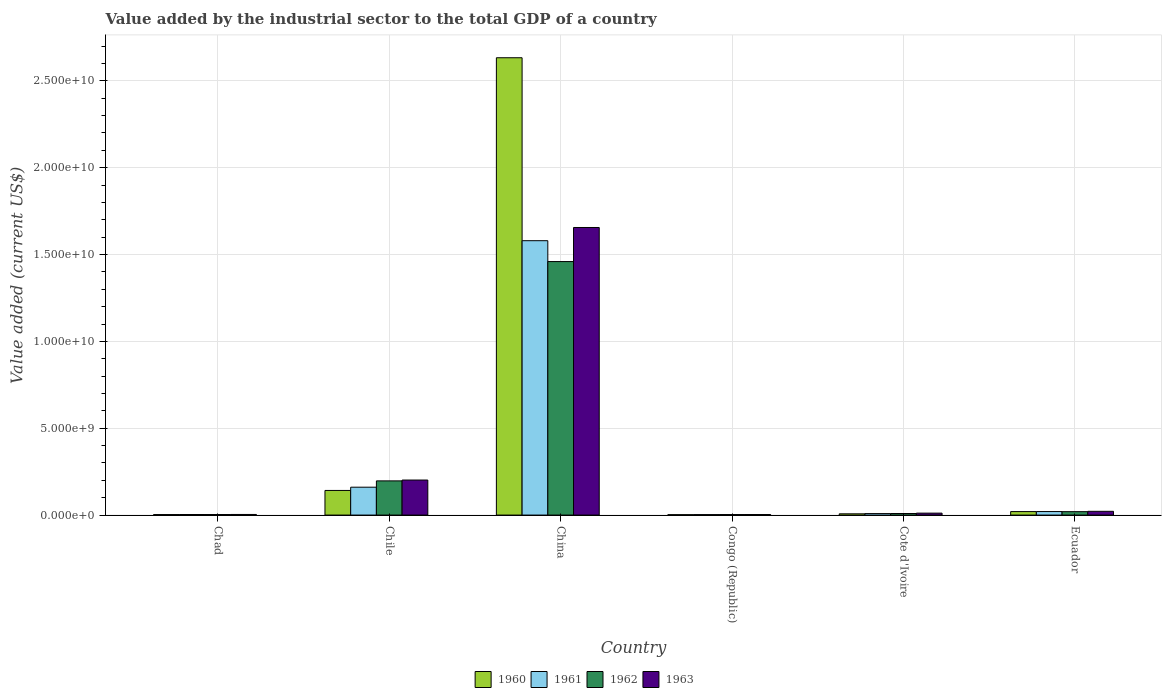How many different coloured bars are there?
Keep it short and to the point. 4. How many groups of bars are there?
Give a very brief answer. 6. How many bars are there on the 5th tick from the left?
Ensure brevity in your answer.  4. How many bars are there on the 5th tick from the right?
Provide a succinct answer. 4. What is the label of the 5th group of bars from the left?
Provide a succinct answer. Cote d'Ivoire. In how many cases, is the number of bars for a given country not equal to the number of legend labels?
Offer a very short reply. 0. What is the value added by the industrial sector to the total GDP in 1961 in China?
Your answer should be very brief. 1.58e+1. Across all countries, what is the maximum value added by the industrial sector to the total GDP in 1962?
Provide a succinct answer. 1.46e+1. Across all countries, what is the minimum value added by the industrial sector to the total GDP in 1963?
Offer a terse response. 3.06e+07. In which country was the value added by the industrial sector to the total GDP in 1960 minimum?
Offer a terse response. Congo (Republic). What is the total value added by the industrial sector to the total GDP in 1962 in the graph?
Give a very brief answer. 1.69e+1. What is the difference between the value added by the industrial sector to the total GDP in 1963 in Chile and that in Cote d'Ivoire?
Ensure brevity in your answer.  1.91e+09. What is the difference between the value added by the industrial sector to the total GDP in 1961 in Congo (Republic) and the value added by the industrial sector to the total GDP in 1960 in Cote d'Ivoire?
Offer a terse response. -4.44e+07. What is the average value added by the industrial sector to the total GDP in 1961 per country?
Keep it short and to the point. 2.96e+09. What is the difference between the value added by the industrial sector to the total GDP of/in 1963 and value added by the industrial sector to the total GDP of/in 1962 in Congo (Republic)?
Provide a short and direct response. 8.16e+05. In how many countries, is the value added by the industrial sector to the total GDP in 1961 greater than 21000000000 US$?
Give a very brief answer. 0. What is the ratio of the value added by the industrial sector to the total GDP in 1962 in Chad to that in Congo (Republic)?
Provide a short and direct response. 1.07. What is the difference between the highest and the second highest value added by the industrial sector to the total GDP in 1963?
Your response must be concise. 1.63e+1. What is the difference between the highest and the lowest value added by the industrial sector to the total GDP in 1961?
Provide a short and direct response. 1.58e+1. In how many countries, is the value added by the industrial sector to the total GDP in 1963 greater than the average value added by the industrial sector to the total GDP in 1963 taken over all countries?
Provide a short and direct response. 1. Is the sum of the value added by the industrial sector to the total GDP in 1960 in Chad and Chile greater than the maximum value added by the industrial sector to the total GDP in 1961 across all countries?
Ensure brevity in your answer.  No. What does the 1st bar from the left in Chile represents?
Your answer should be compact. 1960. How many bars are there?
Your response must be concise. 24. Are all the bars in the graph horizontal?
Your response must be concise. No. What is the difference between two consecutive major ticks on the Y-axis?
Offer a very short reply. 5.00e+09. Are the values on the major ticks of Y-axis written in scientific E-notation?
Keep it short and to the point. Yes. Does the graph contain any zero values?
Your answer should be very brief. No. Does the graph contain grids?
Provide a succinct answer. Yes. Where does the legend appear in the graph?
Your response must be concise. Bottom center. How many legend labels are there?
Offer a very short reply. 4. How are the legend labels stacked?
Your answer should be very brief. Horizontal. What is the title of the graph?
Make the answer very short. Value added by the industrial sector to the total GDP of a country. What is the label or title of the X-axis?
Your answer should be compact. Country. What is the label or title of the Y-axis?
Make the answer very short. Value added (current US$). What is the Value added (current US$) of 1960 in Chad?
Offer a terse response. 2.88e+07. What is the Value added (current US$) in 1961 in Chad?
Your answer should be very brief. 3.27e+07. What is the Value added (current US$) in 1962 in Chad?
Offer a very short reply. 3.17e+07. What is the Value added (current US$) of 1963 in Chad?
Provide a succinct answer. 3.49e+07. What is the Value added (current US$) in 1960 in Chile?
Give a very brief answer. 1.42e+09. What is the Value added (current US$) in 1961 in Chile?
Your response must be concise. 1.61e+09. What is the Value added (current US$) of 1962 in Chile?
Provide a succinct answer. 1.97e+09. What is the Value added (current US$) of 1963 in Chile?
Make the answer very short. 2.02e+09. What is the Value added (current US$) in 1960 in China?
Offer a terse response. 2.63e+1. What is the Value added (current US$) of 1961 in China?
Keep it short and to the point. 1.58e+1. What is the Value added (current US$) of 1962 in China?
Your answer should be compact. 1.46e+1. What is the Value added (current US$) of 1963 in China?
Make the answer very short. 1.66e+1. What is the Value added (current US$) of 1960 in Congo (Republic)?
Give a very brief answer. 2.24e+07. What is the Value added (current US$) of 1961 in Congo (Republic)?
Offer a terse response. 2.73e+07. What is the Value added (current US$) of 1962 in Congo (Republic)?
Offer a terse response. 2.98e+07. What is the Value added (current US$) of 1963 in Congo (Republic)?
Ensure brevity in your answer.  3.06e+07. What is the Value added (current US$) of 1960 in Cote d'Ivoire?
Offer a terse response. 7.18e+07. What is the Value added (current US$) of 1961 in Cote d'Ivoire?
Keep it short and to the point. 8.58e+07. What is the Value added (current US$) in 1962 in Cote d'Ivoire?
Give a very brief answer. 9.02e+07. What is the Value added (current US$) of 1963 in Cote d'Ivoire?
Keep it short and to the point. 1.12e+08. What is the Value added (current US$) of 1960 in Ecuador?
Provide a succinct answer. 2.01e+08. What is the Value added (current US$) of 1961 in Ecuador?
Offer a very short reply. 2.02e+08. What is the Value added (current US$) in 1962 in Ecuador?
Ensure brevity in your answer.  1.96e+08. What is the Value added (current US$) in 1963 in Ecuador?
Provide a succinct answer. 2.16e+08. Across all countries, what is the maximum Value added (current US$) in 1960?
Provide a short and direct response. 2.63e+1. Across all countries, what is the maximum Value added (current US$) of 1961?
Your answer should be very brief. 1.58e+1. Across all countries, what is the maximum Value added (current US$) of 1962?
Make the answer very short. 1.46e+1. Across all countries, what is the maximum Value added (current US$) in 1963?
Keep it short and to the point. 1.66e+1. Across all countries, what is the minimum Value added (current US$) of 1960?
Offer a very short reply. 2.24e+07. Across all countries, what is the minimum Value added (current US$) of 1961?
Provide a short and direct response. 2.73e+07. Across all countries, what is the minimum Value added (current US$) of 1962?
Your response must be concise. 2.98e+07. Across all countries, what is the minimum Value added (current US$) in 1963?
Make the answer very short. 3.06e+07. What is the total Value added (current US$) of 1960 in the graph?
Your response must be concise. 2.81e+1. What is the total Value added (current US$) in 1961 in the graph?
Make the answer very short. 1.78e+1. What is the total Value added (current US$) of 1962 in the graph?
Your response must be concise. 1.69e+1. What is the total Value added (current US$) in 1963 in the graph?
Keep it short and to the point. 1.90e+1. What is the difference between the Value added (current US$) in 1960 in Chad and that in Chile?
Give a very brief answer. -1.39e+09. What is the difference between the Value added (current US$) in 1961 in Chad and that in Chile?
Give a very brief answer. -1.57e+09. What is the difference between the Value added (current US$) of 1962 in Chad and that in Chile?
Give a very brief answer. -1.94e+09. What is the difference between the Value added (current US$) of 1963 in Chad and that in Chile?
Ensure brevity in your answer.  -1.98e+09. What is the difference between the Value added (current US$) in 1960 in Chad and that in China?
Offer a terse response. -2.63e+1. What is the difference between the Value added (current US$) of 1961 in Chad and that in China?
Offer a very short reply. -1.58e+1. What is the difference between the Value added (current US$) of 1962 in Chad and that in China?
Your response must be concise. -1.46e+1. What is the difference between the Value added (current US$) in 1963 in Chad and that in China?
Give a very brief answer. -1.65e+1. What is the difference between the Value added (current US$) of 1960 in Chad and that in Congo (Republic)?
Offer a very short reply. 6.40e+06. What is the difference between the Value added (current US$) in 1961 in Chad and that in Congo (Republic)?
Provide a succinct answer. 5.34e+06. What is the difference between the Value added (current US$) of 1962 in Chad and that in Congo (Republic)?
Make the answer very short. 1.94e+06. What is the difference between the Value added (current US$) in 1963 in Chad and that in Congo (Republic)?
Give a very brief answer. 4.26e+06. What is the difference between the Value added (current US$) in 1960 in Chad and that in Cote d'Ivoire?
Offer a terse response. -4.29e+07. What is the difference between the Value added (current US$) in 1961 in Chad and that in Cote d'Ivoire?
Your answer should be very brief. -5.32e+07. What is the difference between the Value added (current US$) of 1962 in Chad and that in Cote d'Ivoire?
Provide a short and direct response. -5.85e+07. What is the difference between the Value added (current US$) of 1963 in Chad and that in Cote d'Ivoire?
Offer a very short reply. -7.70e+07. What is the difference between the Value added (current US$) in 1960 in Chad and that in Ecuador?
Your answer should be compact. -1.72e+08. What is the difference between the Value added (current US$) in 1961 in Chad and that in Ecuador?
Your response must be concise. -1.70e+08. What is the difference between the Value added (current US$) of 1962 in Chad and that in Ecuador?
Your answer should be very brief. -1.64e+08. What is the difference between the Value added (current US$) of 1963 in Chad and that in Ecuador?
Offer a very short reply. -1.81e+08. What is the difference between the Value added (current US$) in 1960 in Chile and that in China?
Make the answer very short. -2.49e+1. What is the difference between the Value added (current US$) in 1961 in Chile and that in China?
Keep it short and to the point. -1.42e+1. What is the difference between the Value added (current US$) of 1962 in Chile and that in China?
Provide a succinct answer. -1.26e+1. What is the difference between the Value added (current US$) in 1963 in Chile and that in China?
Keep it short and to the point. -1.45e+1. What is the difference between the Value added (current US$) in 1960 in Chile and that in Congo (Republic)?
Your response must be concise. 1.40e+09. What is the difference between the Value added (current US$) in 1961 in Chile and that in Congo (Republic)?
Give a very brief answer. 1.58e+09. What is the difference between the Value added (current US$) in 1962 in Chile and that in Congo (Republic)?
Your answer should be very brief. 1.94e+09. What is the difference between the Value added (current US$) of 1963 in Chile and that in Congo (Republic)?
Provide a succinct answer. 1.99e+09. What is the difference between the Value added (current US$) in 1960 in Chile and that in Cote d'Ivoire?
Offer a terse response. 1.35e+09. What is the difference between the Value added (current US$) of 1961 in Chile and that in Cote d'Ivoire?
Give a very brief answer. 1.52e+09. What is the difference between the Value added (current US$) of 1962 in Chile and that in Cote d'Ivoire?
Make the answer very short. 1.88e+09. What is the difference between the Value added (current US$) of 1963 in Chile and that in Cote d'Ivoire?
Your answer should be compact. 1.91e+09. What is the difference between the Value added (current US$) of 1960 in Chile and that in Ecuador?
Offer a terse response. 1.22e+09. What is the difference between the Value added (current US$) of 1961 in Chile and that in Ecuador?
Make the answer very short. 1.40e+09. What is the difference between the Value added (current US$) in 1962 in Chile and that in Ecuador?
Ensure brevity in your answer.  1.77e+09. What is the difference between the Value added (current US$) of 1963 in Chile and that in Ecuador?
Your answer should be very brief. 1.80e+09. What is the difference between the Value added (current US$) of 1960 in China and that in Congo (Republic)?
Keep it short and to the point. 2.63e+1. What is the difference between the Value added (current US$) of 1961 in China and that in Congo (Republic)?
Offer a terse response. 1.58e+1. What is the difference between the Value added (current US$) in 1962 in China and that in Congo (Republic)?
Your answer should be compact. 1.46e+1. What is the difference between the Value added (current US$) of 1963 in China and that in Congo (Republic)?
Keep it short and to the point. 1.65e+1. What is the difference between the Value added (current US$) in 1960 in China and that in Cote d'Ivoire?
Provide a succinct answer. 2.63e+1. What is the difference between the Value added (current US$) in 1961 in China and that in Cote d'Ivoire?
Keep it short and to the point. 1.57e+1. What is the difference between the Value added (current US$) of 1962 in China and that in Cote d'Ivoire?
Your answer should be compact. 1.45e+1. What is the difference between the Value added (current US$) of 1963 in China and that in Cote d'Ivoire?
Offer a very short reply. 1.64e+1. What is the difference between the Value added (current US$) of 1960 in China and that in Ecuador?
Provide a succinct answer. 2.61e+1. What is the difference between the Value added (current US$) in 1961 in China and that in Ecuador?
Your answer should be very brief. 1.56e+1. What is the difference between the Value added (current US$) in 1962 in China and that in Ecuador?
Give a very brief answer. 1.44e+1. What is the difference between the Value added (current US$) in 1963 in China and that in Ecuador?
Keep it short and to the point. 1.63e+1. What is the difference between the Value added (current US$) in 1960 in Congo (Republic) and that in Cote d'Ivoire?
Give a very brief answer. -4.93e+07. What is the difference between the Value added (current US$) of 1961 in Congo (Republic) and that in Cote d'Ivoire?
Provide a short and direct response. -5.85e+07. What is the difference between the Value added (current US$) in 1962 in Congo (Republic) and that in Cote d'Ivoire?
Provide a short and direct response. -6.04e+07. What is the difference between the Value added (current US$) in 1963 in Congo (Republic) and that in Cote d'Ivoire?
Your answer should be very brief. -8.13e+07. What is the difference between the Value added (current US$) in 1960 in Congo (Republic) and that in Ecuador?
Offer a very short reply. -1.78e+08. What is the difference between the Value added (current US$) in 1961 in Congo (Republic) and that in Ecuador?
Ensure brevity in your answer.  -1.75e+08. What is the difference between the Value added (current US$) in 1962 in Congo (Republic) and that in Ecuador?
Your answer should be very brief. -1.66e+08. What is the difference between the Value added (current US$) in 1963 in Congo (Republic) and that in Ecuador?
Your answer should be very brief. -1.85e+08. What is the difference between the Value added (current US$) in 1960 in Cote d'Ivoire and that in Ecuador?
Provide a short and direct response. -1.29e+08. What is the difference between the Value added (current US$) in 1961 in Cote d'Ivoire and that in Ecuador?
Your response must be concise. -1.16e+08. What is the difference between the Value added (current US$) of 1962 in Cote d'Ivoire and that in Ecuador?
Keep it short and to the point. -1.06e+08. What is the difference between the Value added (current US$) of 1963 in Cote d'Ivoire and that in Ecuador?
Offer a very short reply. -1.04e+08. What is the difference between the Value added (current US$) of 1960 in Chad and the Value added (current US$) of 1961 in Chile?
Your answer should be compact. -1.58e+09. What is the difference between the Value added (current US$) of 1960 in Chad and the Value added (current US$) of 1962 in Chile?
Keep it short and to the point. -1.94e+09. What is the difference between the Value added (current US$) in 1960 in Chad and the Value added (current US$) in 1963 in Chile?
Ensure brevity in your answer.  -1.99e+09. What is the difference between the Value added (current US$) in 1961 in Chad and the Value added (current US$) in 1962 in Chile?
Your answer should be very brief. -1.94e+09. What is the difference between the Value added (current US$) of 1961 in Chad and the Value added (current US$) of 1963 in Chile?
Provide a succinct answer. -1.98e+09. What is the difference between the Value added (current US$) in 1962 in Chad and the Value added (current US$) in 1963 in Chile?
Give a very brief answer. -1.99e+09. What is the difference between the Value added (current US$) of 1960 in Chad and the Value added (current US$) of 1961 in China?
Your answer should be very brief. -1.58e+1. What is the difference between the Value added (current US$) in 1960 in Chad and the Value added (current US$) in 1962 in China?
Offer a terse response. -1.46e+1. What is the difference between the Value added (current US$) in 1960 in Chad and the Value added (current US$) in 1963 in China?
Offer a terse response. -1.65e+1. What is the difference between the Value added (current US$) in 1961 in Chad and the Value added (current US$) in 1962 in China?
Your response must be concise. -1.46e+1. What is the difference between the Value added (current US$) in 1961 in Chad and the Value added (current US$) in 1963 in China?
Provide a short and direct response. -1.65e+1. What is the difference between the Value added (current US$) in 1962 in Chad and the Value added (current US$) in 1963 in China?
Ensure brevity in your answer.  -1.65e+1. What is the difference between the Value added (current US$) of 1960 in Chad and the Value added (current US$) of 1961 in Congo (Republic)?
Your answer should be compact. 1.52e+06. What is the difference between the Value added (current US$) in 1960 in Chad and the Value added (current US$) in 1962 in Congo (Republic)?
Give a very brief answer. -9.61e+05. What is the difference between the Value added (current US$) in 1960 in Chad and the Value added (current US$) in 1963 in Congo (Republic)?
Your answer should be compact. -1.78e+06. What is the difference between the Value added (current US$) in 1961 in Chad and the Value added (current US$) in 1962 in Congo (Republic)?
Provide a short and direct response. 2.86e+06. What is the difference between the Value added (current US$) of 1961 in Chad and the Value added (current US$) of 1963 in Congo (Republic)?
Provide a succinct answer. 2.04e+06. What is the difference between the Value added (current US$) in 1962 in Chad and the Value added (current US$) in 1963 in Congo (Republic)?
Provide a short and direct response. 1.12e+06. What is the difference between the Value added (current US$) of 1960 in Chad and the Value added (current US$) of 1961 in Cote d'Ivoire?
Your response must be concise. -5.70e+07. What is the difference between the Value added (current US$) in 1960 in Chad and the Value added (current US$) in 1962 in Cote d'Ivoire?
Ensure brevity in your answer.  -6.14e+07. What is the difference between the Value added (current US$) of 1960 in Chad and the Value added (current US$) of 1963 in Cote d'Ivoire?
Make the answer very short. -8.30e+07. What is the difference between the Value added (current US$) of 1961 in Chad and the Value added (current US$) of 1962 in Cote d'Ivoire?
Ensure brevity in your answer.  -5.76e+07. What is the difference between the Value added (current US$) in 1961 in Chad and the Value added (current US$) in 1963 in Cote d'Ivoire?
Offer a very short reply. -7.92e+07. What is the difference between the Value added (current US$) in 1962 in Chad and the Value added (current US$) in 1963 in Cote d'Ivoire?
Offer a very short reply. -8.01e+07. What is the difference between the Value added (current US$) in 1960 in Chad and the Value added (current US$) in 1961 in Ecuador?
Keep it short and to the point. -1.73e+08. What is the difference between the Value added (current US$) in 1960 in Chad and the Value added (current US$) in 1962 in Ecuador?
Your answer should be very brief. -1.67e+08. What is the difference between the Value added (current US$) of 1960 in Chad and the Value added (current US$) of 1963 in Ecuador?
Your response must be concise. -1.87e+08. What is the difference between the Value added (current US$) of 1961 in Chad and the Value added (current US$) of 1962 in Ecuador?
Offer a very short reply. -1.64e+08. What is the difference between the Value added (current US$) of 1961 in Chad and the Value added (current US$) of 1963 in Ecuador?
Your answer should be very brief. -1.83e+08. What is the difference between the Value added (current US$) in 1962 in Chad and the Value added (current US$) in 1963 in Ecuador?
Ensure brevity in your answer.  -1.84e+08. What is the difference between the Value added (current US$) of 1960 in Chile and the Value added (current US$) of 1961 in China?
Offer a terse response. -1.44e+1. What is the difference between the Value added (current US$) of 1960 in Chile and the Value added (current US$) of 1962 in China?
Your response must be concise. -1.32e+1. What is the difference between the Value added (current US$) of 1960 in Chile and the Value added (current US$) of 1963 in China?
Provide a succinct answer. -1.51e+1. What is the difference between the Value added (current US$) in 1961 in Chile and the Value added (current US$) in 1962 in China?
Provide a short and direct response. -1.30e+1. What is the difference between the Value added (current US$) in 1961 in Chile and the Value added (current US$) in 1963 in China?
Your answer should be very brief. -1.50e+1. What is the difference between the Value added (current US$) in 1962 in Chile and the Value added (current US$) in 1963 in China?
Your answer should be very brief. -1.46e+1. What is the difference between the Value added (current US$) in 1960 in Chile and the Value added (current US$) in 1961 in Congo (Republic)?
Keep it short and to the point. 1.39e+09. What is the difference between the Value added (current US$) of 1960 in Chile and the Value added (current US$) of 1962 in Congo (Republic)?
Offer a terse response. 1.39e+09. What is the difference between the Value added (current US$) of 1960 in Chile and the Value added (current US$) of 1963 in Congo (Republic)?
Ensure brevity in your answer.  1.39e+09. What is the difference between the Value added (current US$) in 1961 in Chile and the Value added (current US$) in 1962 in Congo (Republic)?
Ensure brevity in your answer.  1.58e+09. What is the difference between the Value added (current US$) in 1961 in Chile and the Value added (current US$) in 1963 in Congo (Republic)?
Your response must be concise. 1.57e+09. What is the difference between the Value added (current US$) in 1962 in Chile and the Value added (current US$) in 1963 in Congo (Republic)?
Offer a very short reply. 1.94e+09. What is the difference between the Value added (current US$) of 1960 in Chile and the Value added (current US$) of 1961 in Cote d'Ivoire?
Your answer should be compact. 1.33e+09. What is the difference between the Value added (current US$) of 1960 in Chile and the Value added (current US$) of 1962 in Cote d'Ivoire?
Ensure brevity in your answer.  1.33e+09. What is the difference between the Value added (current US$) of 1960 in Chile and the Value added (current US$) of 1963 in Cote d'Ivoire?
Your response must be concise. 1.31e+09. What is the difference between the Value added (current US$) of 1961 in Chile and the Value added (current US$) of 1962 in Cote d'Ivoire?
Give a very brief answer. 1.52e+09. What is the difference between the Value added (current US$) of 1961 in Chile and the Value added (current US$) of 1963 in Cote d'Ivoire?
Offer a very short reply. 1.49e+09. What is the difference between the Value added (current US$) in 1962 in Chile and the Value added (current US$) in 1963 in Cote d'Ivoire?
Offer a terse response. 1.86e+09. What is the difference between the Value added (current US$) of 1960 in Chile and the Value added (current US$) of 1961 in Ecuador?
Offer a terse response. 1.22e+09. What is the difference between the Value added (current US$) of 1960 in Chile and the Value added (current US$) of 1962 in Ecuador?
Keep it short and to the point. 1.22e+09. What is the difference between the Value added (current US$) of 1960 in Chile and the Value added (current US$) of 1963 in Ecuador?
Ensure brevity in your answer.  1.20e+09. What is the difference between the Value added (current US$) in 1961 in Chile and the Value added (current US$) in 1962 in Ecuador?
Provide a short and direct response. 1.41e+09. What is the difference between the Value added (current US$) in 1961 in Chile and the Value added (current US$) in 1963 in Ecuador?
Ensure brevity in your answer.  1.39e+09. What is the difference between the Value added (current US$) in 1962 in Chile and the Value added (current US$) in 1963 in Ecuador?
Offer a terse response. 1.75e+09. What is the difference between the Value added (current US$) of 1960 in China and the Value added (current US$) of 1961 in Congo (Republic)?
Make the answer very short. 2.63e+1. What is the difference between the Value added (current US$) of 1960 in China and the Value added (current US$) of 1962 in Congo (Republic)?
Give a very brief answer. 2.63e+1. What is the difference between the Value added (current US$) of 1960 in China and the Value added (current US$) of 1963 in Congo (Republic)?
Offer a terse response. 2.63e+1. What is the difference between the Value added (current US$) of 1961 in China and the Value added (current US$) of 1962 in Congo (Republic)?
Your answer should be very brief. 1.58e+1. What is the difference between the Value added (current US$) of 1961 in China and the Value added (current US$) of 1963 in Congo (Republic)?
Provide a succinct answer. 1.58e+1. What is the difference between the Value added (current US$) of 1962 in China and the Value added (current US$) of 1963 in Congo (Republic)?
Give a very brief answer. 1.46e+1. What is the difference between the Value added (current US$) in 1960 in China and the Value added (current US$) in 1961 in Cote d'Ivoire?
Provide a succinct answer. 2.62e+1. What is the difference between the Value added (current US$) in 1960 in China and the Value added (current US$) in 1962 in Cote d'Ivoire?
Your response must be concise. 2.62e+1. What is the difference between the Value added (current US$) of 1960 in China and the Value added (current US$) of 1963 in Cote d'Ivoire?
Offer a very short reply. 2.62e+1. What is the difference between the Value added (current US$) in 1961 in China and the Value added (current US$) in 1962 in Cote d'Ivoire?
Keep it short and to the point. 1.57e+1. What is the difference between the Value added (current US$) of 1961 in China and the Value added (current US$) of 1963 in Cote d'Ivoire?
Give a very brief answer. 1.57e+1. What is the difference between the Value added (current US$) in 1962 in China and the Value added (current US$) in 1963 in Cote d'Ivoire?
Your answer should be very brief. 1.45e+1. What is the difference between the Value added (current US$) in 1960 in China and the Value added (current US$) in 1961 in Ecuador?
Your response must be concise. 2.61e+1. What is the difference between the Value added (current US$) in 1960 in China and the Value added (current US$) in 1962 in Ecuador?
Keep it short and to the point. 2.61e+1. What is the difference between the Value added (current US$) of 1960 in China and the Value added (current US$) of 1963 in Ecuador?
Keep it short and to the point. 2.61e+1. What is the difference between the Value added (current US$) in 1961 in China and the Value added (current US$) in 1962 in Ecuador?
Your answer should be compact. 1.56e+1. What is the difference between the Value added (current US$) of 1961 in China and the Value added (current US$) of 1963 in Ecuador?
Your answer should be compact. 1.56e+1. What is the difference between the Value added (current US$) of 1962 in China and the Value added (current US$) of 1963 in Ecuador?
Offer a terse response. 1.44e+1. What is the difference between the Value added (current US$) in 1960 in Congo (Republic) and the Value added (current US$) in 1961 in Cote d'Ivoire?
Ensure brevity in your answer.  -6.34e+07. What is the difference between the Value added (current US$) in 1960 in Congo (Republic) and the Value added (current US$) in 1962 in Cote d'Ivoire?
Your answer should be very brief. -6.78e+07. What is the difference between the Value added (current US$) in 1960 in Congo (Republic) and the Value added (current US$) in 1963 in Cote d'Ivoire?
Make the answer very short. -8.94e+07. What is the difference between the Value added (current US$) in 1961 in Congo (Republic) and the Value added (current US$) in 1962 in Cote d'Ivoire?
Offer a very short reply. -6.29e+07. What is the difference between the Value added (current US$) of 1961 in Congo (Republic) and the Value added (current US$) of 1963 in Cote d'Ivoire?
Provide a succinct answer. -8.46e+07. What is the difference between the Value added (current US$) of 1962 in Congo (Republic) and the Value added (current US$) of 1963 in Cote d'Ivoire?
Ensure brevity in your answer.  -8.21e+07. What is the difference between the Value added (current US$) in 1960 in Congo (Republic) and the Value added (current US$) in 1961 in Ecuador?
Ensure brevity in your answer.  -1.80e+08. What is the difference between the Value added (current US$) of 1960 in Congo (Republic) and the Value added (current US$) of 1962 in Ecuador?
Keep it short and to the point. -1.74e+08. What is the difference between the Value added (current US$) of 1960 in Congo (Republic) and the Value added (current US$) of 1963 in Ecuador?
Provide a succinct answer. -1.94e+08. What is the difference between the Value added (current US$) in 1961 in Congo (Republic) and the Value added (current US$) in 1962 in Ecuador?
Keep it short and to the point. -1.69e+08. What is the difference between the Value added (current US$) in 1961 in Congo (Republic) and the Value added (current US$) in 1963 in Ecuador?
Keep it short and to the point. -1.89e+08. What is the difference between the Value added (current US$) in 1962 in Congo (Republic) and the Value added (current US$) in 1963 in Ecuador?
Make the answer very short. -1.86e+08. What is the difference between the Value added (current US$) in 1960 in Cote d'Ivoire and the Value added (current US$) in 1961 in Ecuador?
Offer a terse response. -1.30e+08. What is the difference between the Value added (current US$) of 1960 in Cote d'Ivoire and the Value added (current US$) of 1962 in Ecuador?
Ensure brevity in your answer.  -1.24e+08. What is the difference between the Value added (current US$) of 1960 in Cote d'Ivoire and the Value added (current US$) of 1963 in Ecuador?
Give a very brief answer. -1.44e+08. What is the difference between the Value added (current US$) of 1961 in Cote d'Ivoire and the Value added (current US$) of 1962 in Ecuador?
Make the answer very short. -1.10e+08. What is the difference between the Value added (current US$) of 1961 in Cote d'Ivoire and the Value added (current US$) of 1963 in Ecuador?
Your response must be concise. -1.30e+08. What is the difference between the Value added (current US$) in 1962 in Cote d'Ivoire and the Value added (current US$) in 1963 in Ecuador?
Offer a terse response. -1.26e+08. What is the average Value added (current US$) of 1960 per country?
Give a very brief answer. 4.68e+09. What is the average Value added (current US$) of 1961 per country?
Offer a very short reply. 2.96e+09. What is the average Value added (current US$) in 1962 per country?
Your answer should be very brief. 2.82e+09. What is the average Value added (current US$) of 1963 per country?
Provide a short and direct response. 3.16e+09. What is the difference between the Value added (current US$) in 1960 and Value added (current US$) in 1961 in Chad?
Your answer should be very brief. -3.82e+06. What is the difference between the Value added (current US$) of 1960 and Value added (current US$) of 1962 in Chad?
Provide a short and direct response. -2.90e+06. What is the difference between the Value added (current US$) of 1960 and Value added (current US$) of 1963 in Chad?
Keep it short and to the point. -6.04e+06. What is the difference between the Value added (current US$) of 1961 and Value added (current US$) of 1962 in Chad?
Your answer should be compact. 9.19e+05. What is the difference between the Value added (current US$) in 1961 and Value added (current US$) in 1963 in Chad?
Ensure brevity in your answer.  -2.22e+06. What is the difference between the Value added (current US$) of 1962 and Value added (current US$) of 1963 in Chad?
Keep it short and to the point. -3.14e+06. What is the difference between the Value added (current US$) of 1960 and Value added (current US$) of 1961 in Chile?
Keep it short and to the point. -1.88e+08. What is the difference between the Value added (current US$) in 1960 and Value added (current US$) in 1962 in Chile?
Make the answer very short. -5.50e+08. What is the difference between the Value added (current US$) of 1960 and Value added (current US$) of 1963 in Chile?
Offer a very short reply. -5.99e+08. What is the difference between the Value added (current US$) in 1961 and Value added (current US$) in 1962 in Chile?
Keep it short and to the point. -3.63e+08. What is the difference between the Value added (current US$) of 1961 and Value added (current US$) of 1963 in Chile?
Your answer should be compact. -4.12e+08. What is the difference between the Value added (current US$) of 1962 and Value added (current US$) of 1963 in Chile?
Keep it short and to the point. -4.92e+07. What is the difference between the Value added (current US$) in 1960 and Value added (current US$) in 1961 in China?
Provide a short and direct response. 1.05e+1. What is the difference between the Value added (current US$) in 1960 and Value added (current US$) in 1962 in China?
Make the answer very short. 1.17e+1. What is the difference between the Value added (current US$) of 1960 and Value added (current US$) of 1963 in China?
Give a very brief answer. 9.77e+09. What is the difference between the Value added (current US$) in 1961 and Value added (current US$) in 1962 in China?
Your answer should be very brief. 1.20e+09. What is the difference between the Value added (current US$) in 1961 and Value added (current US$) in 1963 in China?
Make the answer very short. -7.60e+08. What is the difference between the Value added (current US$) of 1962 and Value added (current US$) of 1963 in China?
Your response must be concise. -1.96e+09. What is the difference between the Value added (current US$) in 1960 and Value added (current US$) in 1961 in Congo (Republic)?
Provide a succinct answer. -4.89e+06. What is the difference between the Value added (current US$) of 1960 and Value added (current US$) of 1962 in Congo (Republic)?
Offer a terse response. -7.36e+06. What is the difference between the Value added (current US$) in 1960 and Value added (current US$) in 1963 in Congo (Republic)?
Ensure brevity in your answer.  -8.18e+06. What is the difference between the Value added (current US$) of 1961 and Value added (current US$) of 1962 in Congo (Republic)?
Provide a succinct answer. -2.48e+06. What is the difference between the Value added (current US$) in 1961 and Value added (current US$) in 1963 in Congo (Republic)?
Give a very brief answer. -3.29e+06. What is the difference between the Value added (current US$) of 1962 and Value added (current US$) of 1963 in Congo (Republic)?
Provide a succinct answer. -8.16e+05. What is the difference between the Value added (current US$) in 1960 and Value added (current US$) in 1961 in Cote d'Ivoire?
Make the answer very short. -1.40e+07. What is the difference between the Value added (current US$) of 1960 and Value added (current US$) of 1962 in Cote d'Ivoire?
Keep it short and to the point. -1.85e+07. What is the difference between the Value added (current US$) of 1960 and Value added (current US$) of 1963 in Cote d'Ivoire?
Provide a succinct answer. -4.01e+07. What is the difference between the Value added (current US$) in 1961 and Value added (current US$) in 1962 in Cote d'Ivoire?
Keep it short and to the point. -4.42e+06. What is the difference between the Value added (current US$) of 1961 and Value added (current US$) of 1963 in Cote d'Ivoire?
Offer a very short reply. -2.61e+07. What is the difference between the Value added (current US$) in 1962 and Value added (current US$) in 1963 in Cote d'Ivoire?
Ensure brevity in your answer.  -2.17e+07. What is the difference between the Value added (current US$) in 1960 and Value added (current US$) in 1961 in Ecuador?
Your answer should be very brief. -1.51e+06. What is the difference between the Value added (current US$) of 1960 and Value added (current US$) of 1962 in Ecuador?
Your response must be concise. 4.47e+06. What is the difference between the Value added (current US$) in 1960 and Value added (current US$) in 1963 in Ecuador?
Make the answer very short. -1.55e+07. What is the difference between the Value added (current US$) in 1961 and Value added (current US$) in 1962 in Ecuador?
Your answer should be very brief. 5.98e+06. What is the difference between the Value added (current US$) in 1961 and Value added (current US$) in 1963 in Ecuador?
Your answer should be very brief. -1.39e+07. What is the difference between the Value added (current US$) of 1962 and Value added (current US$) of 1963 in Ecuador?
Provide a short and direct response. -1.99e+07. What is the ratio of the Value added (current US$) of 1960 in Chad to that in Chile?
Keep it short and to the point. 0.02. What is the ratio of the Value added (current US$) of 1961 in Chad to that in Chile?
Offer a very short reply. 0.02. What is the ratio of the Value added (current US$) of 1962 in Chad to that in Chile?
Offer a very short reply. 0.02. What is the ratio of the Value added (current US$) of 1963 in Chad to that in Chile?
Keep it short and to the point. 0.02. What is the ratio of the Value added (current US$) of 1960 in Chad to that in China?
Your answer should be compact. 0. What is the ratio of the Value added (current US$) of 1961 in Chad to that in China?
Ensure brevity in your answer.  0. What is the ratio of the Value added (current US$) of 1962 in Chad to that in China?
Offer a very short reply. 0. What is the ratio of the Value added (current US$) in 1963 in Chad to that in China?
Give a very brief answer. 0. What is the ratio of the Value added (current US$) of 1960 in Chad to that in Congo (Republic)?
Provide a short and direct response. 1.29. What is the ratio of the Value added (current US$) in 1961 in Chad to that in Congo (Republic)?
Offer a very short reply. 1.2. What is the ratio of the Value added (current US$) of 1962 in Chad to that in Congo (Republic)?
Make the answer very short. 1.07. What is the ratio of the Value added (current US$) in 1963 in Chad to that in Congo (Republic)?
Keep it short and to the point. 1.14. What is the ratio of the Value added (current US$) in 1960 in Chad to that in Cote d'Ivoire?
Your response must be concise. 0.4. What is the ratio of the Value added (current US$) of 1961 in Chad to that in Cote d'Ivoire?
Make the answer very short. 0.38. What is the ratio of the Value added (current US$) in 1962 in Chad to that in Cote d'Ivoire?
Your answer should be very brief. 0.35. What is the ratio of the Value added (current US$) in 1963 in Chad to that in Cote d'Ivoire?
Provide a succinct answer. 0.31. What is the ratio of the Value added (current US$) of 1960 in Chad to that in Ecuador?
Your response must be concise. 0.14. What is the ratio of the Value added (current US$) of 1961 in Chad to that in Ecuador?
Ensure brevity in your answer.  0.16. What is the ratio of the Value added (current US$) in 1962 in Chad to that in Ecuador?
Your answer should be compact. 0.16. What is the ratio of the Value added (current US$) of 1963 in Chad to that in Ecuador?
Your answer should be compact. 0.16. What is the ratio of the Value added (current US$) in 1960 in Chile to that in China?
Ensure brevity in your answer.  0.05. What is the ratio of the Value added (current US$) in 1961 in Chile to that in China?
Give a very brief answer. 0.1. What is the ratio of the Value added (current US$) in 1962 in Chile to that in China?
Your answer should be very brief. 0.13. What is the ratio of the Value added (current US$) in 1963 in Chile to that in China?
Keep it short and to the point. 0.12. What is the ratio of the Value added (current US$) of 1960 in Chile to that in Congo (Republic)?
Your answer should be very brief. 63.21. What is the ratio of the Value added (current US$) in 1961 in Chile to that in Congo (Republic)?
Ensure brevity in your answer.  58.77. What is the ratio of the Value added (current US$) of 1962 in Chile to that in Congo (Republic)?
Give a very brief answer. 66.06. What is the ratio of the Value added (current US$) of 1963 in Chile to that in Congo (Republic)?
Give a very brief answer. 65.9. What is the ratio of the Value added (current US$) of 1960 in Chile to that in Cote d'Ivoire?
Give a very brief answer. 19.76. What is the ratio of the Value added (current US$) of 1961 in Chile to that in Cote d'Ivoire?
Your response must be concise. 18.71. What is the ratio of the Value added (current US$) in 1962 in Chile to that in Cote d'Ivoire?
Offer a terse response. 21.81. What is the ratio of the Value added (current US$) of 1963 in Chile to that in Cote d'Ivoire?
Provide a succinct answer. 18.03. What is the ratio of the Value added (current US$) in 1960 in Chile to that in Ecuador?
Make the answer very short. 7.07. What is the ratio of the Value added (current US$) of 1961 in Chile to that in Ecuador?
Make the answer very short. 7.94. What is the ratio of the Value added (current US$) of 1962 in Chile to that in Ecuador?
Your response must be concise. 10.03. What is the ratio of the Value added (current US$) of 1963 in Chile to that in Ecuador?
Keep it short and to the point. 9.34. What is the ratio of the Value added (current US$) of 1960 in China to that in Congo (Republic)?
Make the answer very short. 1173.83. What is the ratio of the Value added (current US$) of 1961 in China to that in Congo (Republic)?
Provide a succinct answer. 578.28. What is the ratio of the Value added (current US$) of 1962 in China to that in Congo (Republic)?
Give a very brief answer. 489.86. What is the ratio of the Value added (current US$) in 1963 in China to that in Congo (Republic)?
Offer a terse response. 540.9. What is the ratio of the Value added (current US$) of 1960 in China to that in Cote d'Ivoire?
Your response must be concise. 366.9. What is the ratio of the Value added (current US$) of 1961 in China to that in Cote d'Ivoire?
Make the answer very short. 184.1. What is the ratio of the Value added (current US$) of 1962 in China to that in Cote d'Ivoire?
Ensure brevity in your answer.  161.77. What is the ratio of the Value added (current US$) of 1963 in China to that in Cote d'Ivoire?
Your response must be concise. 147.99. What is the ratio of the Value added (current US$) of 1960 in China to that in Ecuador?
Make the answer very short. 131.22. What is the ratio of the Value added (current US$) of 1961 in China to that in Ecuador?
Offer a very short reply. 78.14. What is the ratio of the Value added (current US$) of 1962 in China to that in Ecuador?
Provide a succinct answer. 74.39. What is the ratio of the Value added (current US$) in 1963 in China to that in Ecuador?
Ensure brevity in your answer.  76.62. What is the ratio of the Value added (current US$) in 1960 in Congo (Republic) to that in Cote d'Ivoire?
Ensure brevity in your answer.  0.31. What is the ratio of the Value added (current US$) of 1961 in Congo (Republic) to that in Cote d'Ivoire?
Provide a short and direct response. 0.32. What is the ratio of the Value added (current US$) of 1962 in Congo (Republic) to that in Cote d'Ivoire?
Your answer should be compact. 0.33. What is the ratio of the Value added (current US$) in 1963 in Congo (Republic) to that in Cote d'Ivoire?
Your answer should be very brief. 0.27. What is the ratio of the Value added (current US$) of 1960 in Congo (Republic) to that in Ecuador?
Provide a short and direct response. 0.11. What is the ratio of the Value added (current US$) in 1961 in Congo (Republic) to that in Ecuador?
Provide a short and direct response. 0.14. What is the ratio of the Value added (current US$) in 1962 in Congo (Republic) to that in Ecuador?
Your answer should be very brief. 0.15. What is the ratio of the Value added (current US$) in 1963 in Congo (Republic) to that in Ecuador?
Keep it short and to the point. 0.14. What is the ratio of the Value added (current US$) in 1960 in Cote d'Ivoire to that in Ecuador?
Offer a very short reply. 0.36. What is the ratio of the Value added (current US$) of 1961 in Cote d'Ivoire to that in Ecuador?
Keep it short and to the point. 0.42. What is the ratio of the Value added (current US$) of 1962 in Cote d'Ivoire to that in Ecuador?
Ensure brevity in your answer.  0.46. What is the ratio of the Value added (current US$) of 1963 in Cote d'Ivoire to that in Ecuador?
Provide a succinct answer. 0.52. What is the difference between the highest and the second highest Value added (current US$) of 1960?
Offer a terse response. 2.49e+1. What is the difference between the highest and the second highest Value added (current US$) in 1961?
Offer a terse response. 1.42e+1. What is the difference between the highest and the second highest Value added (current US$) in 1962?
Offer a very short reply. 1.26e+1. What is the difference between the highest and the second highest Value added (current US$) in 1963?
Your answer should be compact. 1.45e+1. What is the difference between the highest and the lowest Value added (current US$) of 1960?
Ensure brevity in your answer.  2.63e+1. What is the difference between the highest and the lowest Value added (current US$) in 1961?
Make the answer very short. 1.58e+1. What is the difference between the highest and the lowest Value added (current US$) of 1962?
Make the answer very short. 1.46e+1. What is the difference between the highest and the lowest Value added (current US$) of 1963?
Make the answer very short. 1.65e+1. 